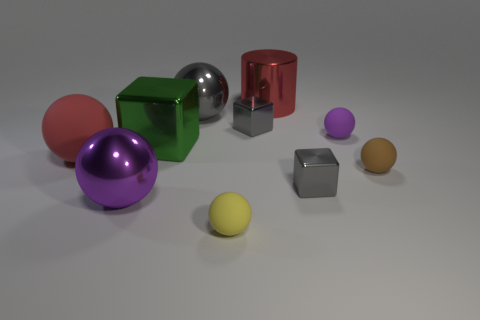How many gray cubes must be subtracted to get 1 gray cubes? 1 Subtract all balls. How many objects are left? 4 Subtract 5 balls. How many balls are left? 1 Subtract all blue cylinders. Subtract all green cubes. How many cylinders are left? 1 Subtract all gray blocks. How many green spheres are left? 0 Subtract all tiny gray objects. Subtract all small purple matte spheres. How many objects are left? 7 Add 9 purple metallic spheres. How many purple metallic spheres are left? 10 Add 8 small gray metallic things. How many small gray metallic things exist? 10 Subtract all gray blocks. How many blocks are left? 1 Subtract all big shiny blocks. How many blocks are left? 2 